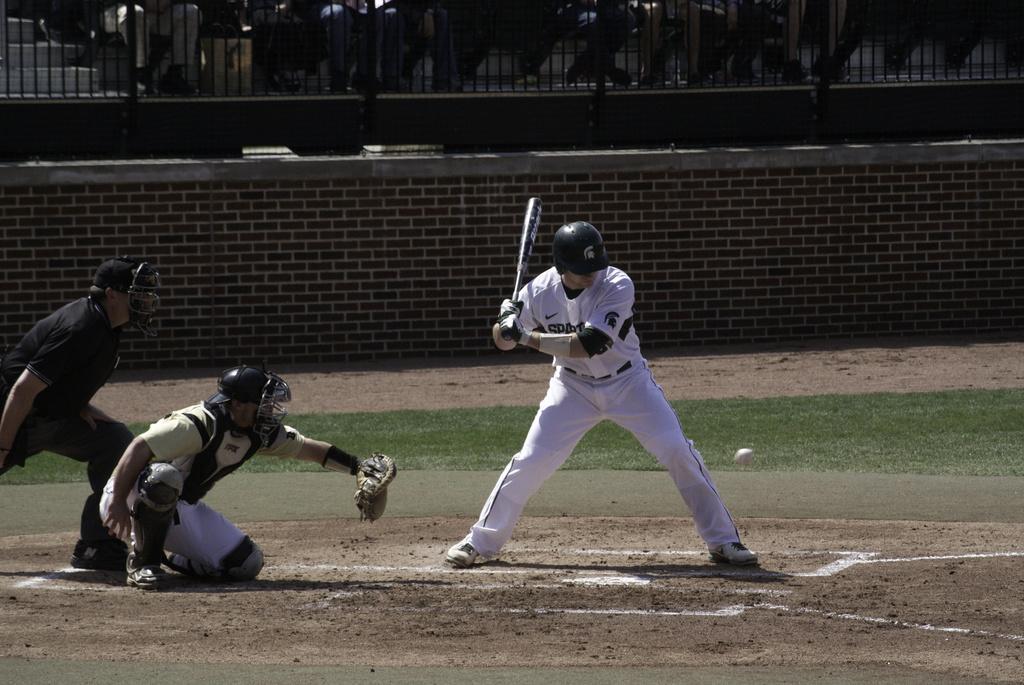How would you summarize this image in a sentence or two? In this picture we can see people playing baseball. In the foreground of the picture we can see three people, soil and grass. In the middle of the picture there are wall and railing. In the background there are trees, staircase and other objects. 